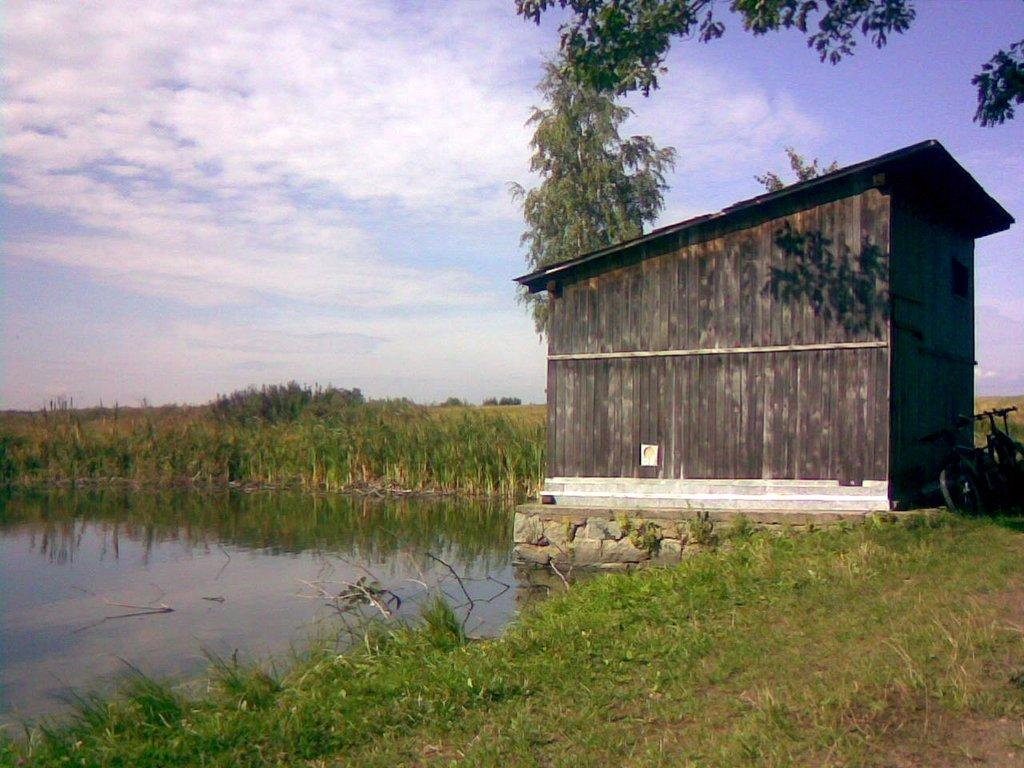What type of terrain is visible in the foreground of the image? There is grassland in the foreground of the image. What objects can be seen in the foreground of the image? There are two bicycles and a shelter in the foreground of the image. What natural elements are visible in the image? There is water, a tree, greenery, and sky visible in the image. Can you describe the weather conditions in the image? The presence of a cloud in the background of the image suggests that it might be partly cloudy. What type of pear is being used as a decoration on the bicycle in the image? There is no pear present in the image; it features a grassland, bicycles, a shelter, water, a tree, greenery, sky, and a cloud. --- Facts: 1. There is a person sitting on a bench in the image. 2. The person is reading a book. 3. There is a tree behind the bench. 4. There is a pond in the background of the image. 5. There are ducks in the pond. Absurd Topics: elephant, piano, volcano Conversation: What is the person in the image doing? The person is sitting on a bench and reading a book. What can be seen behind the bench in the image? There is a tree behind the bench. What is visible in the background of the image? There is a pond in the background of the image. Can you describe the wildlife in the image? There are ducks in the pond. Reasoning: Let's think step by step in order to produce the conversation. We start by identifying the main subject in the image, which is the person sitting on a bench. Then, we describe the activity the person is engaged in, which is reading a book. Next, we mention the objects and natural elements that can be seen in the image, such as the tree and pond. Finally, we acknowledge the presence of ducks in the pond to give a sense of the wildlife in the scene. Absurd Question/Answer: Where is the elephant playing the piano in the image? There is no elephant or piano present in the image; it features a person sitting on a bench, reading a book, a tree, a pond, and ducks. 